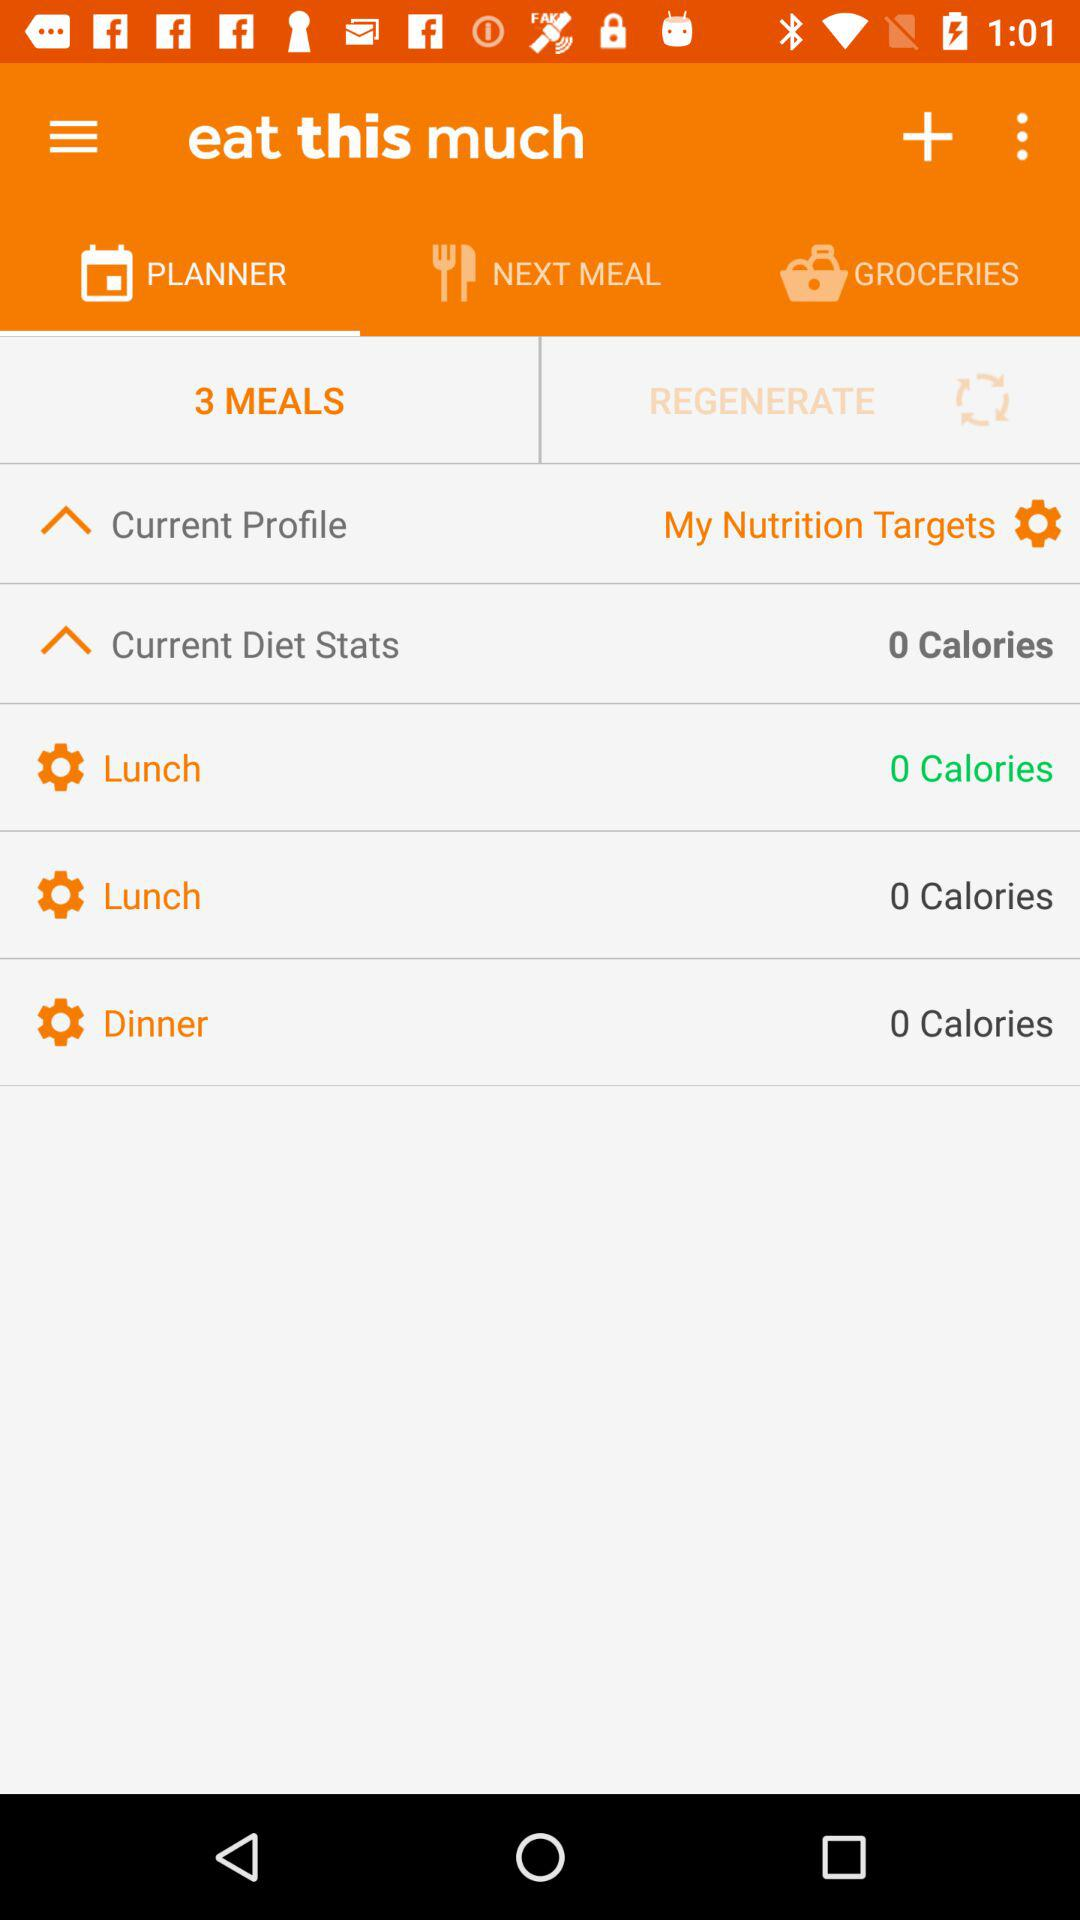How many meals are there in the planner?
Answer the question using a single word or phrase. 3 